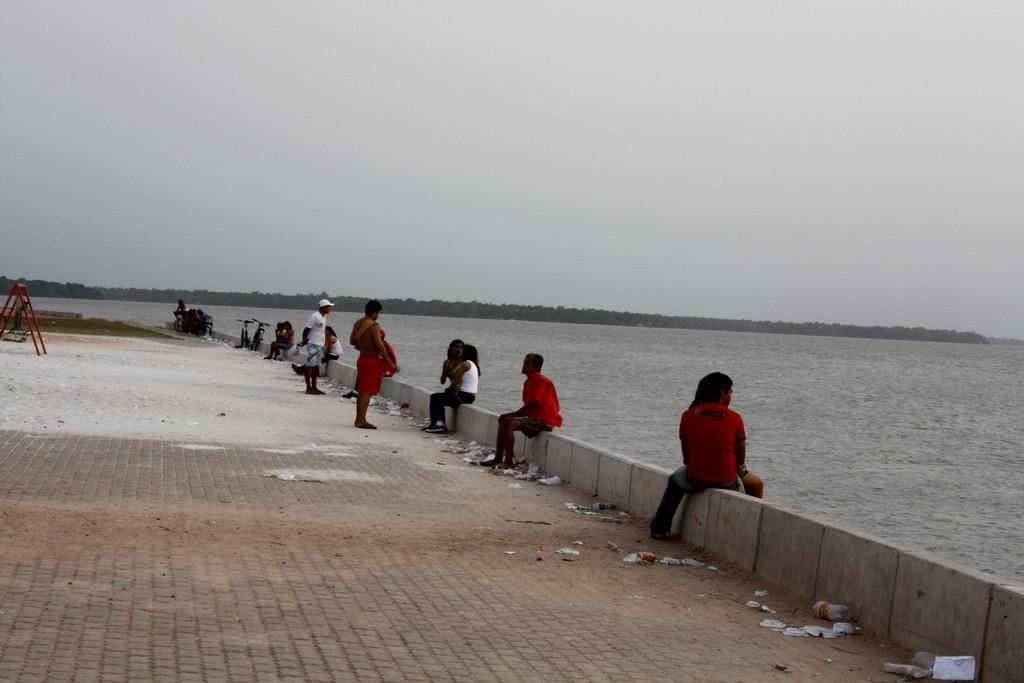Can you describe this image briefly? In this image there is the sky towards the top of the image, there are trees, there is water towards the right of the image, there is ground towards the bottom of the image, there is grass towards the left of the image, there is an object towards the left of the image, there are objects on the ground, there are two bicycles, there are two men standing, there are a group of persons sitting. 